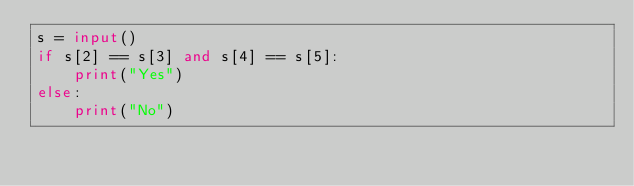<code> <loc_0><loc_0><loc_500><loc_500><_Python_>s = input()
if s[2] == s[3] and s[4] == s[5]:
    print("Yes")
else:
    print("No")</code> 